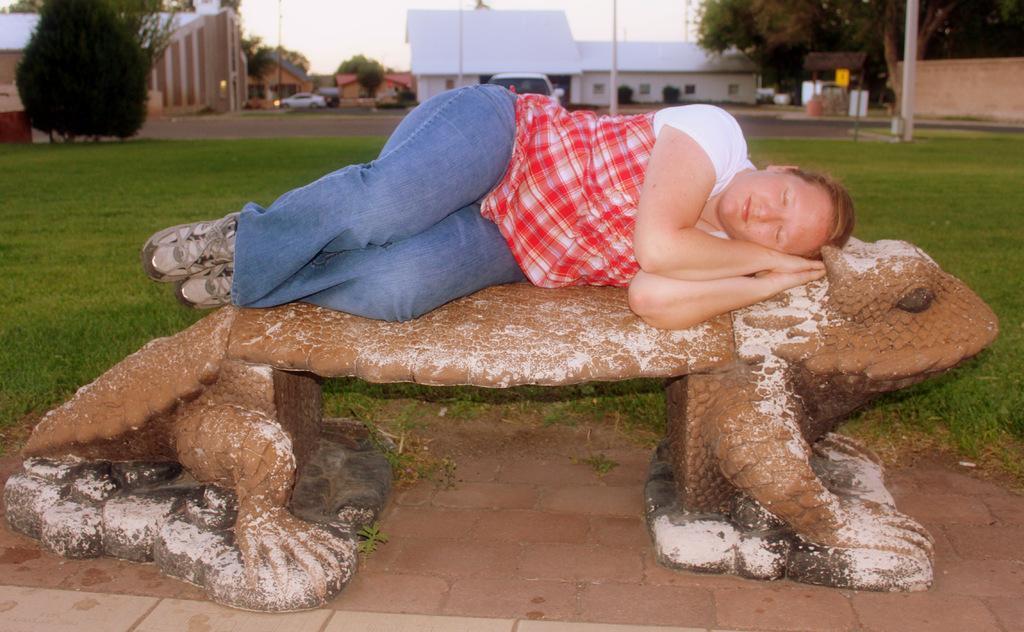Could you give a brief overview of what you see in this image? In this picture we can see a woman lying on a platform, grass, vehicles, trees, buildings, poles and in the background we can see the sky. 